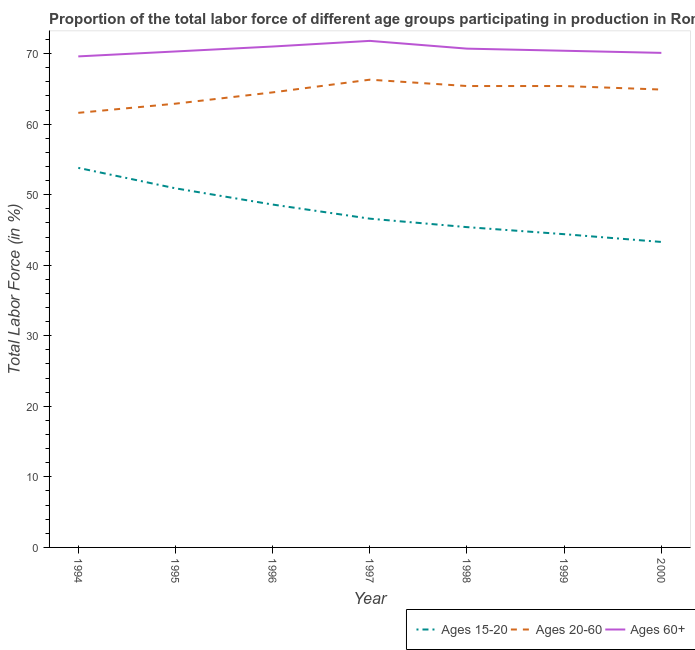How many different coloured lines are there?
Your response must be concise. 3. Does the line corresponding to percentage of labor force above age 60 intersect with the line corresponding to percentage of labor force within the age group 15-20?
Keep it short and to the point. No. What is the percentage of labor force within the age group 20-60 in 1995?
Keep it short and to the point. 62.9. Across all years, what is the maximum percentage of labor force above age 60?
Make the answer very short. 71.8. Across all years, what is the minimum percentage of labor force above age 60?
Provide a succinct answer. 69.6. In which year was the percentage of labor force within the age group 15-20 maximum?
Ensure brevity in your answer.  1994. In which year was the percentage of labor force above age 60 minimum?
Your response must be concise. 1994. What is the total percentage of labor force within the age group 15-20 in the graph?
Your answer should be very brief. 333. What is the difference between the percentage of labor force within the age group 20-60 in 1994 and that in 2000?
Your answer should be very brief. -3.3. What is the difference between the percentage of labor force within the age group 20-60 in 1994 and the percentage of labor force within the age group 15-20 in 1996?
Your answer should be compact. 13. What is the average percentage of labor force above age 60 per year?
Ensure brevity in your answer.  70.56. In the year 1994, what is the difference between the percentage of labor force above age 60 and percentage of labor force within the age group 20-60?
Make the answer very short. 8. What is the ratio of the percentage of labor force above age 60 in 1999 to that in 2000?
Provide a short and direct response. 1. Is the difference between the percentage of labor force within the age group 15-20 in 1996 and 1998 greater than the difference between the percentage of labor force within the age group 20-60 in 1996 and 1998?
Your answer should be compact. Yes. What is the difference between the highest and the second highest percentage of labor force within the age group 20-60?
Ensure brevity in your answer.  0.9. What is the difference between the highest and the lowest percentage of labor force above age 60?
Ensure brevity in your answer.  2.2. Is the sum of the percentage of labor force within the age group 20-60 in 1994 and 2000 greater than the maximum percentage of labor force within the age group 15-20 across all years?
Provide a short and direct response. Yes. Is it the case that in every year, the sum of the percentage of labor force within the age group 15-20 and percentage of labor force within the age group 20-60 is greater than the percentage of labor force above age 60?
Your answer should be compact. Yes. Does the percentage of labor force within the age group 20-60 monotonically increase over the years?
Give a very brief answer. No. Is the percentage of labor force within the age group 15-20 strictly less than the percentage of labor force above age 60 over the years?
Your answer should be very brief. Yes. How many lines are there?
Your response must be concise. 3. How many years are there in the graph?
Your answer should be very brief. 7. What is the difference between two consecutive major ticks on the Y-axis?
Your response must be concise. 10. Are the values on the major ticks of Y-axis written in scientific E-notation?
Your response must be concise. No. Does the graph contain any zero values?
Keep it short and to the point. No. Where does the legend appear in the graph?
Make the answer very short. Bottom right. How many legend labels are there?
Your answer should be compact. 3. What is the title of the graph?
Keep it short and to the point. Proportion of the total labor force of different age groups participating in production in Romania. Does "Agricultural Nitrous Oxide" appear as one of the legend labels in the graph?
Give a very brief answer. No. What is the label or title of the Y-axis?
Give a very brief answer. Total Labor Force (in %). What is the Total Labor Force (in %) of Ages 15-20 in 1994?
Keep it short and to the point. 53.8. What is the Total Labor Force (in %) in Ages 20-60 in 1994?
Offer a terse response. 61.6. What is the Total Labor Force (in %) of Ages 60+ in 1994?
Offer a terse response. 69.6. What is the Total Labor Force (in %) of Ages 15-20 in 1995?
Your response must be concise. 50.9. What is the Total Labor Force (in %) of Ages 20-60 in 1995?
Give a very brief answer. 62.9. What is the Total Labor Force (in %) in Ages 60+ in 1995?
Provide a succinct answer. 70.3. What is the Total Labor Force (in %) in Ages 15-20 in 1996?
Keep it short and to the point. 48.6. What is the Total Labor Force (in %) of Ages 20-60 in 1996?
Ensure brevity in your answer.  64.5. What is the Total Labor Force (in %) in Ages 60+ in 1996?
Provide a succinct answer. 71. What is the Total Labor Force (in %) in Ages 15-20 in 1997?
Keep it short and to the point. 46.6. What is the Total Labor Force (in %) of Ages 20-60 in 1997?
Your response must be concise. 66.3. What is the Total Labor Force (in %) of Ages 60+ in 1997?
Keep it short and to the point. 71.8. What is the Total Labor Force (in %) of Ages 15-20 in 1998?
Keep it short and to the point. 45.4. What is the Total Labor Force (in %) of Ages 20-60 in 1998?
Your answer should be compact. 65.4. What is the Total Labor Force (in %) in Ages 60+ in 1998?
Offer a terse response. 70.7. What is the Total Labor Force (in %) in Ages 15-20 in 1999?
Ensure brevity in your answer.  44.4. What is the Total Labor Force (in %) of Ages 20-60 in 1999?
Keep it short and to the point. 65.4. What is the Total Labor Force (in %) of Ages 60+ in 1999?
Your answer should be very brief. 70.4. What is the Total Labor Force (in %) in Ages 15-20 in 2000?
Your answer should be very brief. 43.3. What is the Total Labor Force (in %) of Ages 20-60 in 2000?
Give a very brief answer. 64.9. What is the Total Labor Force (in %) in Ages 60+ in 2000?
Provide a succinct answer. 70.1. Across all years, what is the maximum Total Labor Force (in %) in Ages 15-20?
Your answer should be very brief. 53.8. Across all years, what is the maximum Total Labor Force (in %) of Ages 20-60?
Your answer should be compact. 66.3. Across all years, what is the maximum Total Labor Force (in %) of Ages 60+?
Your answer should be very brief. 71.8. Across all years, what is the minimum Total Labor Force (in %) of Ages 15-20?
Your answer should be compact. 43.3. Across all years, what is the minimum Total Labor Force (in %) of Ages 20-60?
Your response must be concise. 61.6. Across all years, what is the minimum Total Labor Force (in %) in Ages 60+?
Your answer should be compact. 69.6. What is the total Total Labor Force (in %) in Ages 15-20 in the graph?
Offer a terse response. 333. What is the total Total Labor Force (in %) of Ages 20-60 in the graph?
Give a very brief answer. 451. What is the total Total Labor Force (in %) of Ages 60+ in the graph?
Offer a very short reply. 493.9. What is the difference between the Total Labor Force (in %) of Ages 15-20 in 1994 and that in 1995?
Offer a very short reply. 2.9. What is the difference between the Total Labor Force (in %) in Ages 20-60 in 1994 and that in 1995?
Your answer should be very brief. -1.3. What is the difference between the Total Labor Force (in %) of Ages 60+ in 1994 and that in 1997?
Your answer should be compact. -2.2. What is the difference between the Total Labor Force (in %) of Ages 60+ in 1994 and that in 1998?
Your answer should be very brief. -1.1. What is the difference between the Total Labor Force (in %) of Ages 15-20 in 1994 and that in 1999?
Provide a short and direct response. 9.4. What is the difference between the Total Labor Force (in %) in Ages 20-60 in 1995 and that in 1996?
Ensure brevity in your answer.  -1.6. What is the difference between the Total Labor Force (in %) of Ages 15-20 in 1995 and that in 1997?
Keep it short and to the point. 4.3. What is the difference between the Total Labor Force (in %) of Ages 15-20 in 1995 and that in 1998?
Your response must be concise. 5.5. What is the difference between the Total Labor Force (in %) in Ages 60+ in 1995 and that in 1999?
Provide a short and direct response. -0.1. What is the difference between the Total Labor Force (in %) of Ages 15-20 in 1996 and that in 1997?
Keep it short and to the point. 2. What is the difference between the Total Labor Force (in %) of Ages 20-60 in 1996 and that in 1997?
Keep it short and to the point. -1.8. What is the difference between the Total Labor Force (in %) in Ages 15-20 in 1996 and that in 1999?
Give a very brief answer. 4.2. What is the difference between the Total Labor Force (in %) of Ages 20-60 in 1996 and that in 1999?
Offer a very short reply. -0.9. What is the difference between the Total Labor Force (in %) in Ages 60+ in 1996 and that in 1999?
Offer a very short reply. 0.6. What is the difference between the Total Labor Force (in %) in Ages 20-60 in 1996 and that in 2000?
Keep it short and to the point. -0.4. What is the difference between the Total Labor Force (in %) of Ages 15-20 in 1997 and that in 1998?
Your answer should be compact. 1.2. What is the difference between the Total Labor Force (in %) in Ages 20-60 in 1997 and that in 1998?
Offer a very short reply. 0.9. What is the difference between the Total Labor Force (in %) of Ages 60+ in 1997 and that in 1999?
Offer a terse response. 1.4. What is the difference between the Total Labor Force (in %) in Ages 15-20 in 1997 and that in 2000?
Keep it short and to the point. 3.3. What is the difference between the Total Labor Force (in %) in Ages 20-60 in 1997 and that in 2000?
Your answer should be very brief. 1.4. What is the difference between the Total Labor Force (in %) in Ages 60+ in 1997 and that in 2000?
Your answer should be compact. 1.7. What is the difference between the Total Labor Force (in %) in Ages 60+ in 1998 and that in 1999?
Make the answer very short. 0.3. What is the difference between the Total Labor Force (in %) of Ages 15-20 in 1998 and that in 2000?
Provide a short and direct response. 2.1. What is the difference between the Total Labor Force (in %) of Ages 60+ in 1998 and that in 2000?
Offer a very short reply. 0.6. What is the difference between the Total Labor Force (in %) in Ages 15-20 in 1999 and that in 2000?
Provide a succinct answer. 1.1. What is the difference between the Total Labor Force (in %) of Ages 60+ in 1999 and that in 2000?
Your response must be concise. 0.3. What is the difference between the Total Labor Force (in %) of Ages 15-20 in 1994 and the Total Labor Force (in %) of Ages 20-60 in 1995?
Your response must be concise. -9.1. What is the difference between the Total Labor Force (in %) in Ages 15-20 in 1994 and the Total Labor Force (in %) in Ages 60+ in 1995?
Provide a short and direct response. -16.5. What is the difference between the Total Labor Force (in %) in Ages 20-60 in 1994 and the Total Labor Force (in %) in Ages 60+ in 1995?
Offer a very short reply. -8.7. What is the difference between the Total Labor Force (in %) of Ages 15-20 in 1994 and the Total Labor Force (in %) of Ages 20-60 in 1996?
Keep it short and to the point. -10.7. What is the difference between the Total Labor Force (in %) in Ages 15-20 in 1994 and the Total Labor Force (in %) in Ages 60+ in 1996?
Offer a very short reply. -17.2. What is the difference between the Total Labor Force (in %) in Ages 20-60 in 1994 and the Total Labor Force (in %) in Ages 60+ in 1996?
Offer a terse response. -9.4. What is the difference between the Total Labor Force (in %) in Ages 20-60 in 1994 and the Total Labor Force (in %) in Ages 60+ in 1997?
Give a very brief answer. -10.2. What is the difference between the Total Labor Force (in %) in Ages 15-20 in 1994 and the Total Labor Force (in %) in Ages 20-60 in 1998?
Provide a succinct answer. -11.6. What is the difference between the Total Labor Force (in %) in Ages 15-20 in 1994 and the Total Labor Force (in %) in Ages 60+ in 1998?
Offer a very short reply. -16.9. What is the difference between the Total Labor Force (in %) of Ages 15-20 in 1994 and the Total Labor Force (in %) of Ages 60+ in 1999?
Your response must be concise. -16.6. What is the difference between the Total Labor Force (in %) of Ages 20-60 in 1994 and the Total Labor Force (in %) of Ages 60+ in 1999?
Your response must be concise. -8.8. What is the difference between the Total Labor Force (in %) of Ages 15-20 in 1994 and the Total Labor Force (in %) of Ages 20-60 in 2000?
Your answer should be very brief. -11.1. What is the difference between the Total Labor Force (in %) of Ages 15-20 in 1994 and the Total Labor Force (in %) of Ages 60+ in 2000?
Make the answer very short. -16.3. What is the difference between the Total Labor Force (in %) in Ages 20-60 in 1994 and the Total Labor Force (in %) in Ages 60+ in 2000?
Keep it short and to the point. -8.5. What is the difference between the Total Labor Force (in %) of Ages 15-20 in 1995 and the Total Labor Force (in %) of Ages 20-60 in 1996?
Keep it short and to the point. -13.6. What is the difference between the Total Labor Force (in %) of Ages 15-20 in 1995 and the Total Labor Force (in %) of Ages 60+ in 1996?
Give a very brief answer. -20.1. What is the difference between the Total Labor Force (in %) in Ages 20-60 in 1995 and the Total Labor Force (in %) in Ages 60+ in 1996?
Provide a short and direct response. -8.1. What is the difference between the Total Labor Force (in %) of Ages 15-20 in 1995 and the Total Labor Force (in %) of Ages 20-60 in 1997?
Give a very brief answer. -15.4. What is the difference between the Total Labor Force (in %) of Ages 15-20 in 1995 and the Total Labor Force (in %) of Ages 60+ in 1997?
Offer a very short reply. -20.9. What is the difference between the Total Labor Force (in %) of Ages 20-60 in 1995 and the Total Labor Force (in %) of Ages 60+ in 1997?
Your answer should be compact. -8.9. What is the difference between the Total Labor Force (in %) of Ages 15-20 in 1995 and the Total Labor Force (in %) of Ages 20-60 in 1998?
Provide a short and direct response. -14.5. What is the difference between the Total Labor Force (in %) in Ages 15-20 in 1995 and the Total Labor Force (in %) in Ages 60+ in 1998?
Your answer should be very brief. -19.8. What is the difference between the Total Labor Force (in %) in Ages 20-60 in 1995 and the Total Labor Force (in %) in Ages 60+ in 1998?
Your answer should be very brief. -7.8. What is the difference between the Total Labor Force (in %) of Ages 15-20 in 1995 and the Total Labor Force (in %) of Ages 20-60 in 1999?
Give a very brief answer. -14.5. What is the difference between the Total Labor Force (in %) in Ages 15-20 in 1995 and the Total Labor Force (in %) in Ages 60+ in 1999?
Your response must be concise. -19.5. What is the difference between the Total Labor Force (in %) in Ages 15-20 in 1995 and the Total Labor Force (in %) in Ages 20-60 in 2000?
Provide a succinct answer. -14. What is the difference between the Total Labor Force (in %) in Ages 15-20 in 1995 and the Total Labor Force (in %) in Ages 60+ in 2000?
Keep it short and to the point. -19.2. What is the difference between the Total Labor Force (in %) of Ages 20-60 in 1995 and the Total Labor Force (in %) of Ages 60+ in 2000?
Your answer should be compact. -7.2. What is the difference between the Total Labor Force (in %) of Ages 15-20 in 1996 and the Total Labor Force (in %) of Ages 20-60 in 1997?
Offer a terse response. -17.7. What is the difference between the Total Labor Force (in %) of Ages 15-20 in 1996 and the Total Labor Force (in %) of Ages 60+ in 1997?
Provide a succinct answer. -23.2. What is the difference between the Total Labor Force (in %) in Ages 20-60 in 1996 and the Total Labor Force (in %) in Ages 60+ in 1997?
Keep it short and to the point. -7.3. What is the difference between the Total Labor Force (in %) in Ages 15-20 in 1996 and the Total Labor Force (in %) in Ages 20-60 in 1998?
Ensure brevity in your answer.  -16.8. What is the difference between the Total Labor Force (in %) in Ages 15-20 in 1996 and the Total Labor Force (in %) in Ages 60+ in 1998?
Your answer should be compact. -22.1. What is the difference between the Total Labor Force (in %) of Ages 15-20 in 1996 and the Total Labor Force (in %) of Ages 20-60 in 1999?
Keep it short and to the point. -16.8. What is the difference between the Total Labor Force (in %) of Ages 15-20 in 1996 and the Total Labor Force (in %) of Ages 60+ in 1999?
Provide a short and direct response. -21.8. What is the difference between the Total Labor Force (in %) in Ages 20-60 in 1996 and the Total Labor Force (in %) in Ages 60+ in 1999?
Ensure brevity in your answer.  -5.9. What is the difference between the Total Labor Force (in %) of Ages 15-20 in 1996 and the Total Labor Force (in %) of Ages 20-60 in 2000?
Provide a succinct answer. -16.3. What is the difference between the Total Labor Force (in %) of Ages 15-20 in 1996 and the Total Labor Force (in %) of Ages 60+ in 2000?
Provide a succinct answer. -21.5. What is the difference between the Total Labor Force (in %) in Ages 15-20 in 1997 and the Total Labor Force (in %) in Ages 20-60 in 1998?
Offer a terse response. -18.8. What is the difference between the Total Labor Force (in %) in Ages 15-20 in 1997 and the Total Labor Force (in %) in Ages 60+ in 1998?
Ensure brevity in your answer.  -24.1. What is the difference between the Total Labor Force (in %) in Ages 20-60 in 1997 and the Total Labor Force (in %) in Ages 60+ in 1998?
Provide a short and direct response. -4.4. What is the difference between the Total Labor Force (in %) in Ages 15-20 in 1997 and the Total Labor Force (in %) in Ages 20-60 in 1999?
Make the answer very short. -18.8. What is the difference between the Total Labor Force (in %) of Ages 15-20 in 1997 and the Total Labor Force (in %) of Ages 60+ in 1999?
Your answer should be compact. -23.8. What is the difference between the Total Labor Force (in %) in Ages 15-20 in 1997 and the Total Labor Force (in %) in Ages 20-60 in 2000?
Your response must be concise. -18.3. What is the difference between the Total Labor Force (in %) of Ages 15-20 in 1997 and the Total Labor Force (in %) of Ages 60+ in 2000?
Your answer should be compact. -23.5. What is the difference between the Total Labor Force (in %) in Ages 20-60 in 1997 and the Total Labor Force (in %) in Ages 60+ in 2000?
Your answer should be compact. -3.8. What is the difference between the Total Labor Force (in %) in Ages 15-20 in 1998 and the Total Labor Force (in %) in Ages 60+ in 1999?
Give a very brief answer. -25. What is the difference between the Total Labor Force (in %) of Ages 15-20 in 1998 and the Total Labor Force (in %) of Ages 20-60 in 2000?
Keep it short and to the point. -19.5. What is the difference between the Total Labor Force (in %) in Ages 15-20 in 1998 and the Total Labor Force (in %) in Ages 60+ in 2000?
Provide a succinct answer. -24.7. What is the difference between the Total Labor Force (in %) in Ages 15-20 in 1999 and the Total Labor Force (in %) in Ages 20-60 in 2000?
Provide a succinct answer. -20.5. What is the difference between the Total Labor Force (in %) of Ages 15-20 in 1999 and the Total Labor Force (in %) of Ages 60+ in 2000?
Your answer should be compact. -25.7. What is the average Total Labor Force (in %) in Ages 15-20 per year?
Give a very brief answer. 47.57. What is the average Total Labor Force (in %) in Ages 20-60 per year?
Make the answer very short. 64.43. What is the average Total Labor Force (in %) of Ages 60+ per year?
Provide a short and direct response. 70.56. In the year 1994, what is the difference between the Total Labor Force (in %) in Ages 15-20 and Total Labor Force (in %) in Ages 60+?
Offer a very short reply. -15.8. In the year 1995, what is the difference between the Total Labor Force (in %) of Ages 15-20 and Total Labor Force (in %) of Ages 60+?
Make the answer very short. -19.4. In the year 1996, what is the difference between the Total Labor Force (in %) in Ages 15-20 and Total Labor Force (in %) in Ages 20-60?
Make the answer very short. -15.9. In the year 1996, what is the difference between the Total Labor Force (in %) in Ages 15-20 and Total Labor Force (in %) in Ages 60+?
Offer a very short reply. -22.4. In the year 1997, what is the difference between the Total Labor Force (in %) in Ages 15-20 and Total Labor Force (in %) in Ages 20-60?
Your answer should be very brief. -19.7. In the year 1997, what is the difference between the Total Labor Force (in %) in Ages 15-20 and Total Labor Force (in %) in Ages 60+?
Give a very brief answer. -25.2. In the year 1997, what is the difference between the Total Labor Force (in %) of Ages 20-60 and Total Labor Force (in %) of Ages 60+?
Make the answer very short. -5.5. In the year 1998, what is the difference between the Total Labor Force (in %) in Ages 15-20 and Total Labor Force (in %) in Ages 20-60?
Your answer should be very brief. -20. In the year 1998, what is the difference between the Total Labor Force (in %) of Ages 15-20 and Total Labor Force (in %) of Ages 60+?
Your response must be concise. -25.3. In the year 1998, what is the difference between the Total Labor Force (in %) of Ages 20-60 and Total Labor Force (in %) of Ages 60+?
Keep it short and to the point. -5.3. In the year 1999, what is the difference between the Total Labor Force (in %) in Ages 20-60 and Total Labor Force (in %) in Ages 60+?
Offer a very short reply. -5. In the year 2000, what is the difference between the Total Labor Force (in %) of Ages 15-20 and Total Labor Force (in %) of Ages 20-60?
Your answer should be compact. -21.6. In the year 2000, what is the difference between the Total Labor Force (in %) in Ages 15-20 and Total Labor Force (in %) in Ages 60+?
Provide a short and direct response. -26.8. In the year 2000, what is the difference between the Total Labor Force (in %) of Ages 20-60 and Total Labor Force (in %) of Ages 60+?
Keep it short and to the point. -5.2. What is the ratio of the Total Labor Force (in %) of Ages 15-20 in 1994 to that in 1995?
Make the answer very short. 1.06. What is the ratio of the Total Labor Force (in %) in Ages 20-60 in 1994 to that in 1995?
Keep it short and to the point. 0.98. What is the ratio of the Total Labor Force (in %) in Ages 15-20 in 1994 to that in 1996?
Ensure brevity in your answer.  1.11. What is the ratio of the Total Labor Force (in %) in Ages 20-60 in 1994 to that in 1996?
Keep it short and to the point. 0.95. What is the ratio of the Total Labor Force (in %) of Ages 60+ in 1994 to that in 1996?
Provide a short and direct response. 0.98. What is the ratio of the Total Labor Force (in %) in Ages 15-20 in 1994 to that in 1997?
Make the answer very short. 1.15. What is the ratio of the Total Labor Force (in %) of Ages 20-60 in 1994 to that in 1997?
Your answer should be compact. 0.93. What is the ratio of the Total Labor Force (in %) of Ages 60+ in 1994 to that in 1997?
Ensure brevity in your answer.  0.97. What is the ratio of the Total Labor Force (in %) of Ages 15-20 in 1994 to that in 1998?
Make the answer very short. 1.19. What is the ratio of the Total Labor Force (in %) in Ages 20-60 in 1994 to that in 1998?
Provide a short and direct response. 0.94. What is the ratio of the Total Labor Force (in %) in Ages 60+ in 1994 to that in 1998?
Your response must be concise. 0.98. What is the ratio of the Total Labor Force (in %) of Ages 15-20 in 1994 to that in 1999?
Keep it short and to the point. 1.21. What is the ratio of the Total Labor Force (in %) in Ages 20-60 in 1994 to that in 1999?
Provide a short and direct response. 0.94. What is the ratio of the Total Labor Force (in %) of Ages 15-20 in 1994 to that in 2000?
Make the answer very short. 1.24. What is the ratio of the Total Labor Force (in %) in Ages 20-60 in 1994 to that in 2000?
Ensure brevity in your answer.  0.95. What is the ratio of the Total Labor Force (in %) in Ages 15-20 in 1995 to that in 1996?
Provide a short and direct response. 1.05. What is the ratio of the Total Labor Force (in %) in Ages 20-60 in 1995 to that in 1996?
Your answer should be very brief. 0.98. What is the ratio of the Total Labor Force (in %) of Ages 15-20 in 1995 to that in 1997?
Your answer should be compact. 1.09. What is the ratio of the Total Labor Force (in %) of Ages 20-60 in 1995 to that in 1997?
Your response must be concise. 0.95. What is the ratio of the Total Labor Force (in %) of Ages 60+ in 1995 to that in 1997?
Provide a succinct answer. 0.98. What is the ratio of the Total Labor Force (in %) in Ages 15-20 in 1995 to that in 1998?
Provide a short and direct response. 1.12. What is the ratio of the Total Labor Force (in %) in Ages 20-60 in 1995 to that in 1998?
Provide a succinct answer. 0.96. What is the ratio of the Total Labor Force (in %) of Ages 15-20 in 1995 to that in 1999?
Provide a succinct answer. 1.15. What is the ratio of the Total Labor Force (in %) of Ages 20-60 in 1995 to that in 1999?
Provide a succinct answer. 0.96. What is the ratio of the Total Labor Force (in %) in Ages 15-20 in 1995 to that in 2000?
Your answer should be very brief. 1.18. What is the ratio of the Total Labor Force (in %) in Ages 20-60 in 1995 to that in 2000?
Offer a terse response. 0.97. What is the ratio of the Total Labor Force (in %) in Ages 15-20 in 1996 to that in 1997?
Offer a terse response. 1.04. What is the ratio of the Total Labor Force (in %) of Ages 20-60 in 1996 to that in 1997?
Keep it short and to the point. 0.97. What is the ratio of the Total Labor Force (in %) in Ages 60+ in 1996 to that in 1997?
Keep it short and to the point. 0.99. What is the ratio of the Total Labor Force (in %) in Ages 15-20 in 1996 to that in 1998?
Make the answer very short. 1.07. What is the ratio of the Total Labor Force (in %) in Ages 20-60 in 1996 to that in 1998?
Make the answer very short. 0.99. What is the ratio of the Total Labor Force (in %) of Ages 60+ in 1996 to that in 1998?
Keep it short and to the point. 1. What is the ratio of the Total Labor Force (in %) of Ages 15-20 in 1996 to that in 1999?
Your answer should be very brief. 1.09. What is the ratio of the Total Labor Force (in %) in Ages 20-60 in 1996 to that in 1999?
Provide a short and direct response. 0.99. What is the ratio of the Total Labor Force (in %) in Ages 60+ in 1996 to that in 1999?
Your answer should be compact. 1.01. What is the ratio of the Total Labor Force (in %) of Ages 15-20 in 1996 to that in 2000?
Your response must be concise. 1.12. What is the ratio of the Total Labor Force (in %) in Ages 20-60 in 1996 to that in 2000?
Ensure brevity in your answer.  0.99. What is the ratio of the Total Labor Force (in %) in Ages 60+ in 1996 to that in 2000?
Provide a short and direct response. 1.01. What is the ratio of the Total Labor Force (in %) in Ages 15-20 in 1997 to that in 1998?
Offer a terse response. 1.03. What is the ratio of the Total Labor Force (in %) in Ages 20-60 in 1997 to that in 1998?
Provide a succinct answer. 1.01. What is the ratio of the Total Labor Force (in %) of Ages 60+ in 1997 to that in 1998?
Keep it short and to the point. 1.02. What is the ratio of the Total Labor Force (in %) in Ages 15-20 in 1997 to that in 1999?
Make the answer very short. 1.05. What is the ratio of the Total Labor Force (in %) of Ages 20-60 in 1997 to that in 1999?
Provide a short and direct response. 1.01. What is the ratio of the Total Labor Force (in %) of Ages 60+ in 1997 to that in 1999?
Offer a terse response. 1.02. What is the ratio of the Total Labor Force (in %) of Ages 15-20 in 1997 to that in 2000?
Provide a succinct answer. 1.08. What is the ratio of the Total Labor Force (in %) in Ages 20-60 in 1997 to that in 2000?
Offer a very short reply. 1.02. What is the ratio of the Total Labor Force (in %) in Ages 60+ in 1997 to that in 2000?
Provide a short and direct response. 1.02. What is the ratio of the Total Labor Force (in %) of Ages 15-20 in 1998 to that in 1999?
Give a very brief answer. 1.02. What is the ratio of the Total Labor Force (in %) of Ages 15-20 in 1998 to that in 2000?
Your answer should be compact. 1.05. What is the ratio of the Total Labor Force (in %) of Ages 20-60 in 1998 to that in 2000?
Give a very brief answer. 1.01. What is the ratio of the Total Labor Force (in %) in Ages 60+ in 1998 to that in 2000?
Ensure brevity in your answer.  1.01. What is the ratio of the Total Labor Force (in %) in Ages 15-20 in 1999 to that in 2000?
Offer a terse response. 1.03. What is the ratio of the Total Labor Force (in %) of Ages 20-60 in 1999 to that in 2000?
Provide a succinct answer. 1.01. What is the ratio of the Total Labor Force (in %) in Ages 60+ in 1999 to that in 2000?
Ensure brevity in your answer.  1. What is the difference between the highest and the second highest Total Labor Force (in %) of Ages 15-20?
Offer a terse response. 2.9. What is the difference between the highest and the second highest Total Labor Force (in %) of Ages 20-60?
Make the answer very short. 0.9. What is the difference between the highest and the second highest Total Labor Force (in %) of Ages 60+?
Give a very brief answer. 0.8. What is the difference between the highest and the lowest Total Labor Force (in %) of Ages 15-20?
Your answer should be very brief. 10.5. What is the difference between the highest and the lowest Total Labor Force (in %) in Ages 20-60?
Provide a short and direct response. 4.7. 